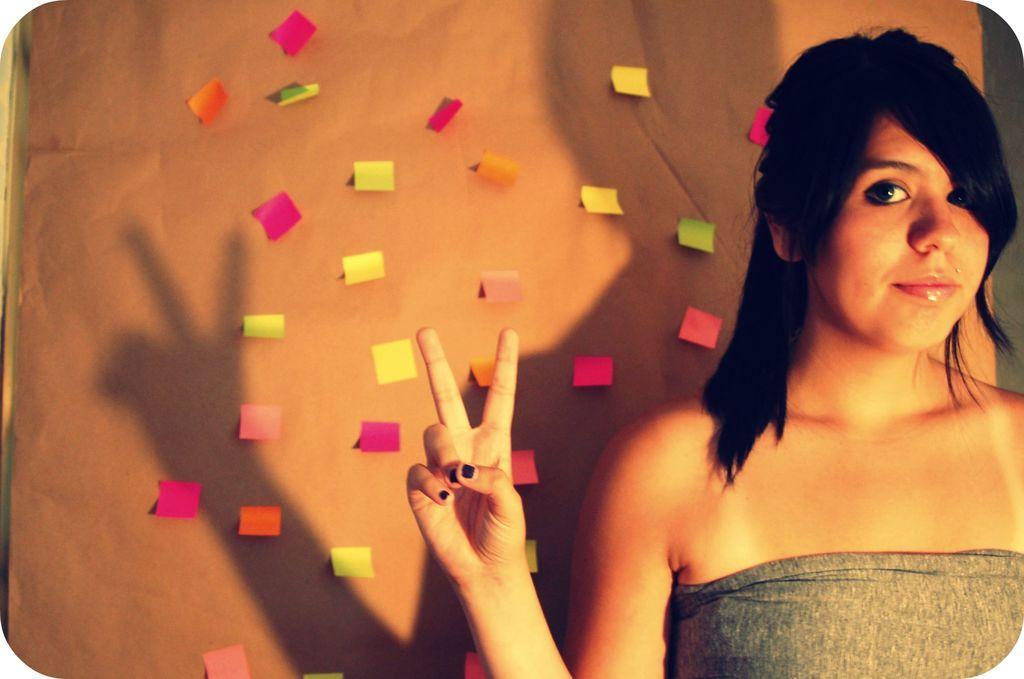How would you summarize this image in a sentence or two? In the image we can see there is a woman standing and behind there are paper clips on the wall. 